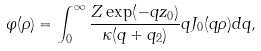Convert formula to latex. <formula><loc_0><loc_0><loc_500><loc_500>\varphi ( \rho ) = \int _ { 0 } ^ { \infty } \frac { Z \exp ( - q z _ { 0 } ) } { \kappa ( q + q _ { 2 } ) } q J _ { 0 } ( q \rho ) d q ,</formula> 